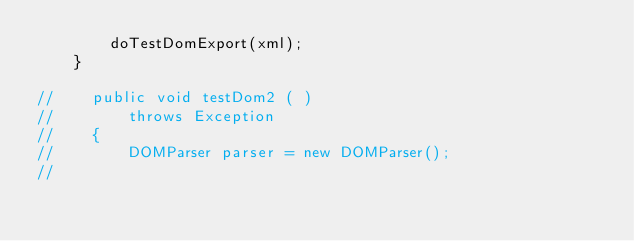Convert code to text. <code><loc_0><loc_0><loc_500><loc_500><_Java_>        doTestDomExport(xml);
    }

//    public void testDom2 ( )
//        throws Exception
//    {
//        DOMParser parser = new DOMParser();
//</code> 